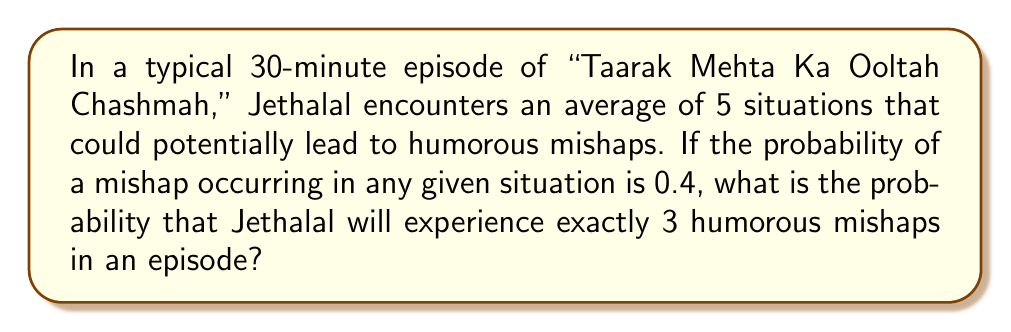Help me with this question. To solve this problem, we need to use the binomial probability formula. The scenario fits a binomial distribution because:

1. There are a fixed number of trials (5 situations).
2. Each trial has two possible outcomes (mishap occurs or doesn't occur).
3. The probability of success (mishap occurring) is constant for each trial.
4. The trials are independent.

The binomial probability formula is:

$$ P(X = k) = \binom{n}{k} p^k (1-p)^{n-k} $$

Where:
- $n$ is the number of trials (5 situations)
- $k$ is the number of successes (3 mishaps)
- $p$ is the probability of success on each trial (0.4)

Let's substitute these values:

$$ P(X = 3) = \binom{5}{3} (0.4)^3 (1-0.4)^{5-3} $$

Step 1: Calculate the binomial coefficient:
$$ \binom{5}{3} = \frac{5!}{3!(5-3)!} = \frac{5 \cdot 4 \cdot 3}{3 \cdot 2 \cdot 1} = 10 $$

Step 2: Calculate the probabilities:
$$ (0.4)^3 = 0.064 $$
$$ (1-0.4)^{5-3} = (0.6)^2 = 0.36 $$

Step 3: Multiply all parts:
$$ 10 \cdot 0.064 \cdot 0.36 = 0.2304 $$

Therefore, the probability of Jethalal experiencing exactly 3 humorous mishaps in an episode is 0.2304 or about 23.04%.
Answer: 0.2304 